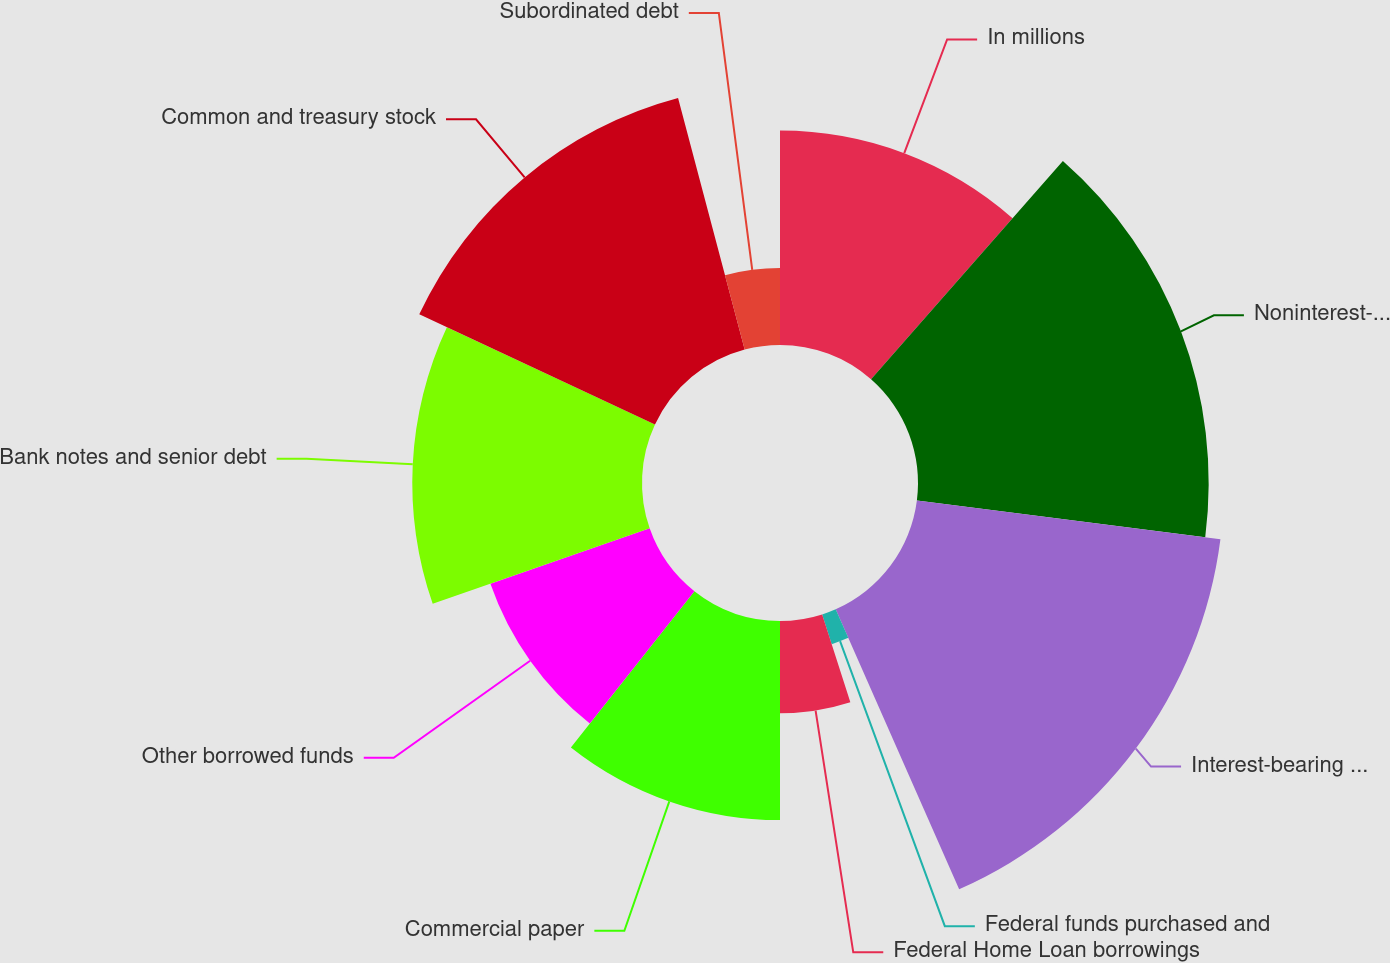Convert chart. <chart><loc_0><loc_0><loc_500><loc_500><pie_chart><fcel>In millions<fcel>Noninterest-bearing deposits<fcel>Interest-bearing deposits<fcel>Federal funds purchased and<fcel>Federal Home Loan borrowings<fcel>Commercial paper<fcel>Other borrowed funds<fcel>Bank notes and senior debt<fcel>Common and treasury stock<fcel>Subordinated debt<nl><fcel>11.47%<fcel>15.55%<fcel>16.37%<fcel>1.67%<fcel>4.94%<fcel>10.65%<fcel>9.02%<fcel>12.29%<fcel>13.92%<fcel>4.12%<nl></chart> 